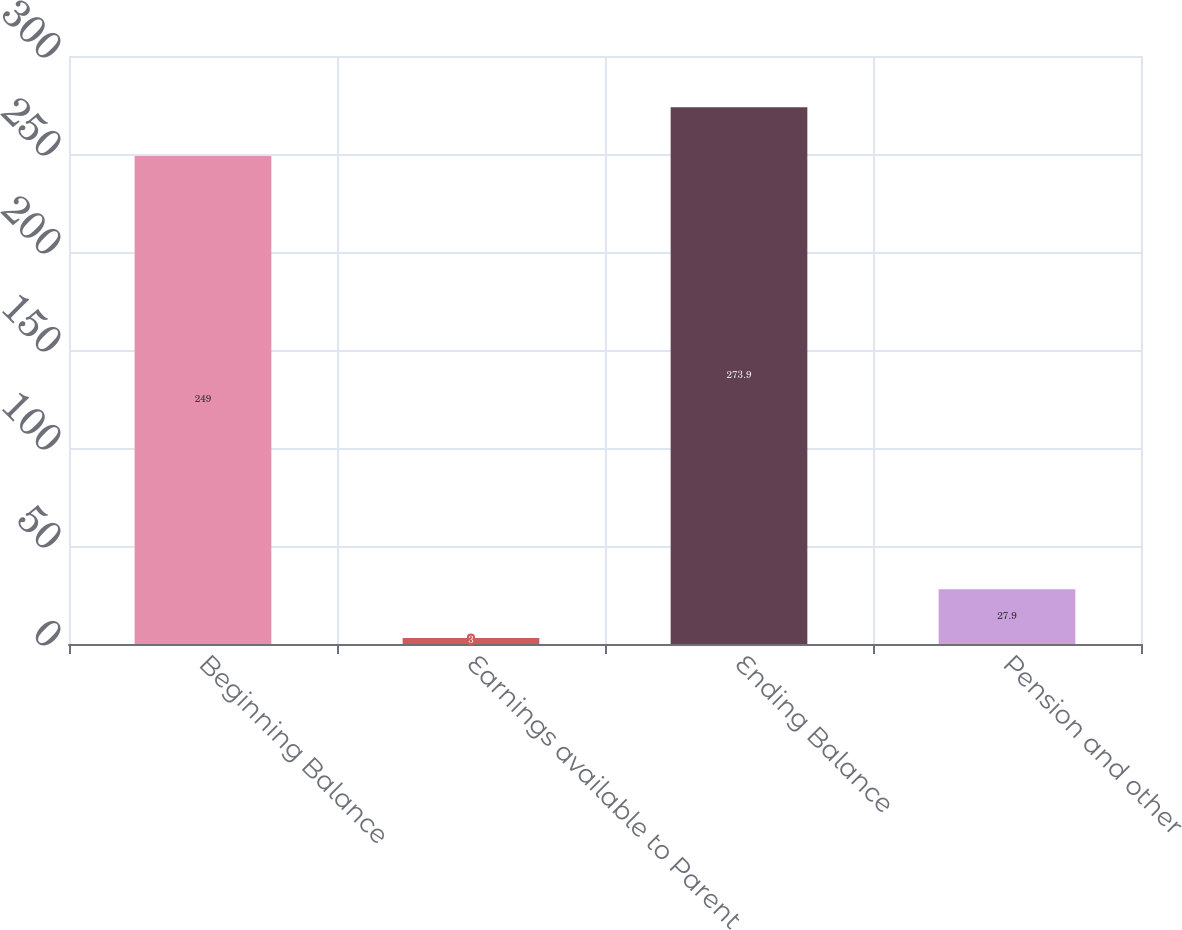Convert chart. <chart><loc_0><loc_0><loc_500><loc_500><bar_chart><fcel>Beginning Balance<fcel>Earnings available to Parent<fcel>Ending Balance<fcel>Pension and other<nl><fcel>249<fcel>3<fcel>273.9<fcel>27.9<nl></chart> 